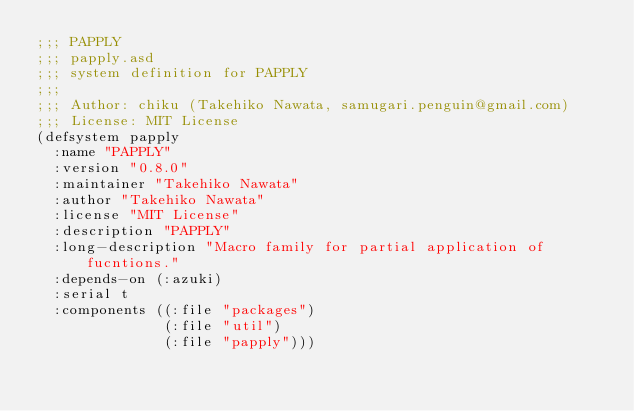<code> <loc_0><loc_0><loc_500><loc_500><_Lisp_>;;; PAPPLY
;;; papply.asd
;;; system definition for PAPPLY
;;;
;;; Author: chiku (Takehiko Nawata, samugari.penguin@gmail.com)
;;; License: MIT License
(defsystem papply
  :name "PAPPLY"
  :version "0.8.0"
  :maintainer "Takehiko Nawata"
  :author "Takehiko Nawata"
  :license "MIT License"
  :description "PAPPLY"
  :long-description "Macro family for partial application of fucntions."
  :depends-on (:azuki)
  :serial t
  :components ((:file "packages")
               (:file "util")
               (:file "papply")))
</code> 